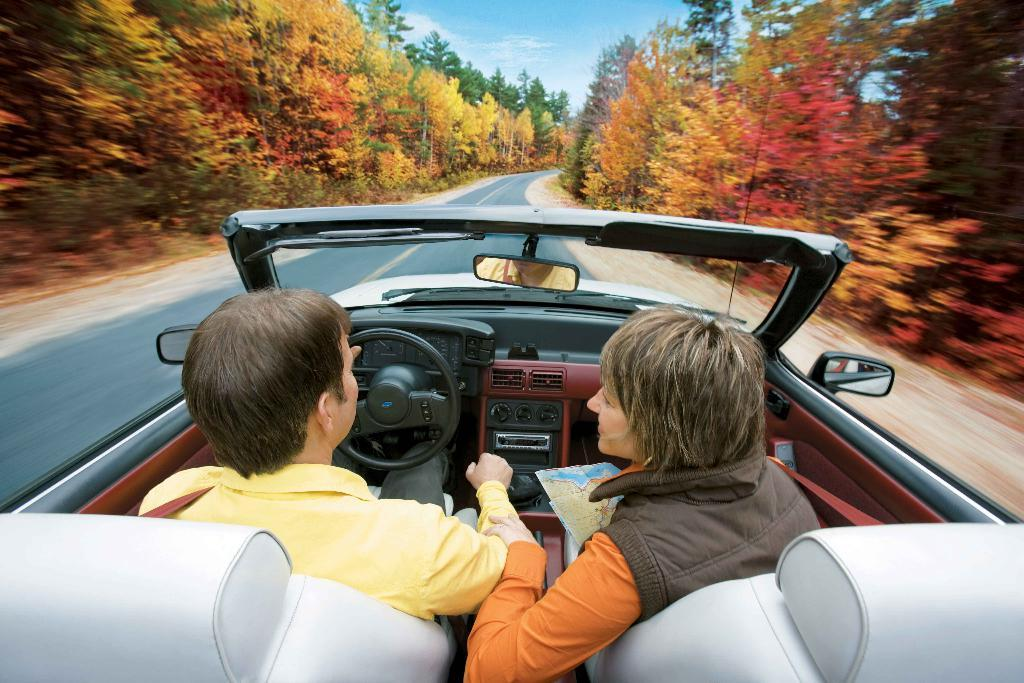How many people are in the image? There are two persons in the image. What are the two persons doing in the image? The two persons are riding a car. Where is the car located in the image? The car is on the road. What can be seen in front of the car? There are trees visible in front of the car. What is visible in the background of the image? The sky is visible in the image. What direction are the persons in the image heading, according to the north? The image does not provide any information about the direction the persons are heading, nor does it mention the north. 